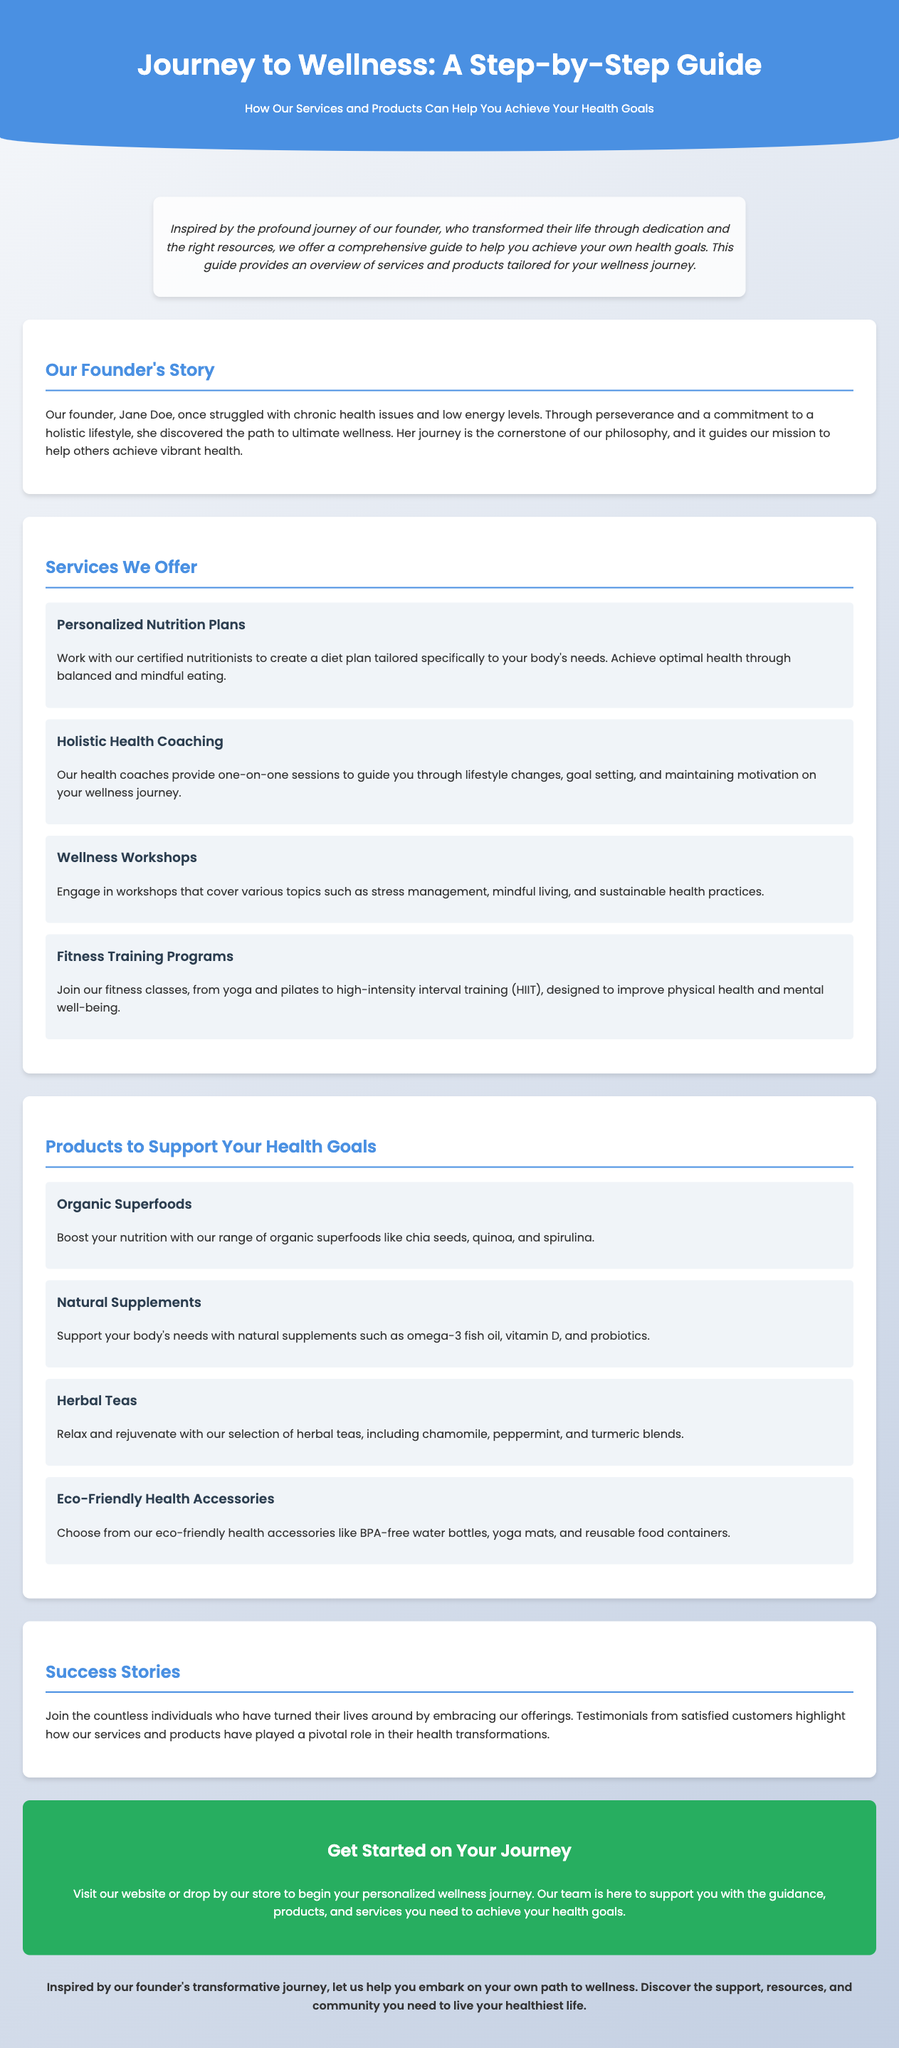What is the title of the guide? The title is prominently displayed in the header of the document.
Answer: Journey to Wellness: A Step-by-Step Guide Who is the founder mentioned in the document? The founder's name is provided in the section discussing their story.
Answer: Jane Doe What type of plans do the nutritionists create? The document specifies the nature of the plans offered by nutritionists.
Answer: Personalized Nutrition Plans What do wellness workshops cover? The document describes the topics included in the wellness workshops.
Answer: Various topics such as stress management, mindful living, and sustainable health practices What types of products support health goals? The document lists the categories of products offered to customers.
Answer: Organic Superfoods, Natural Supplements, Herbal Teas, Eco-Friendly Health Accessories How many fitness training program types are mentioned? The document enumerates the types of fitness programs in the corresponding section.
Answer: Four types What is the main purpose of holistic health coaching? The document states the primary function of the coaching services offered.
Answer: To guide you through lifestyle changes, goal setting, and maintaining motivation What should customers do to get started on their journey? The document provides a call to action for potential customers.
Answer: Visit our website or drop by our store 